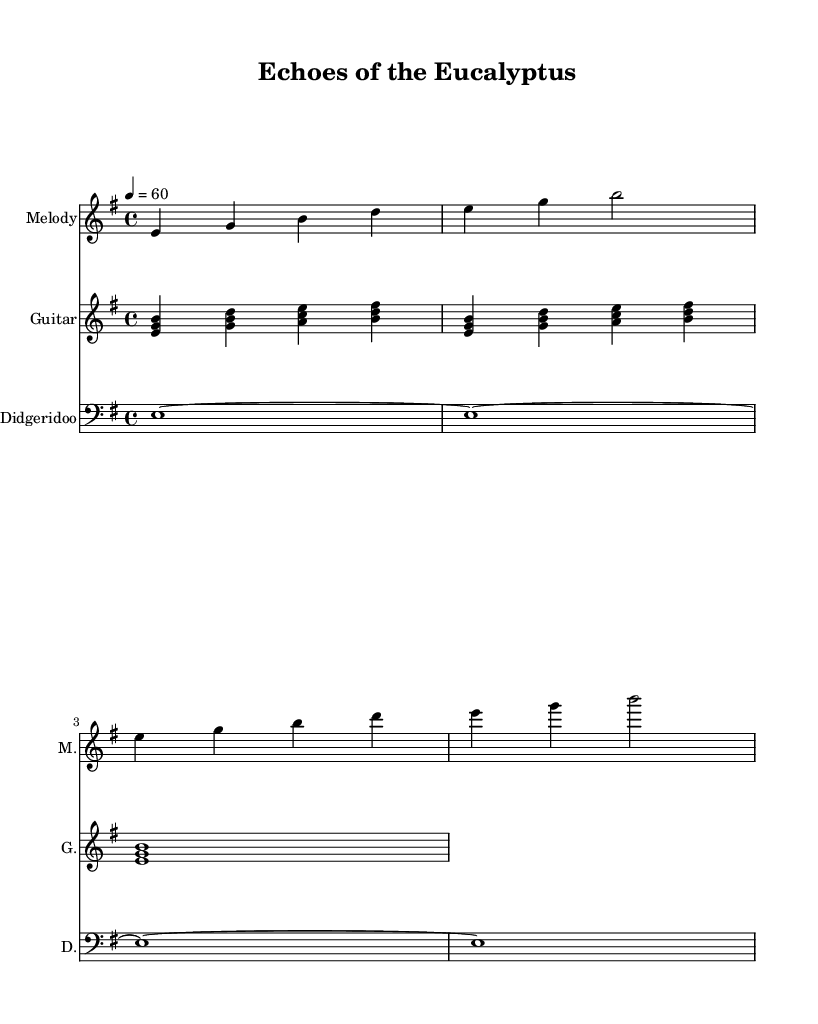What is the key signature of this music? The key signature is E minor, which has one sharp (F#). This can be identified by looking at the key signature at the beginning of the staff lines.
Answer: E minor What is the time signature of this piece? The time signature is 4/4, noted right after the key signature at the beginning of the score. This means there are four beats in a measure and the quarter note gets one beat.
Answer: 4/4 What is the tempo marking of the piece? The tempo marking is quarter note equals 60, which can be found in the header section of the music. This indicates that a quarter note gets a beats per minute count of 60.
Answer: 60 How many measures are in the melody section? The melody section contains four measures. This can be counted by looking at the vertical lines separating the measures in the melody staff.
Answer: 4 What instruments are featured in this piece? The instruments featured are melody, guitar, and didgeridoo. These are listed at the beginning of each respective staff.
Answer: Melody, Guitar, Didgeridoo What is the duration of the didgeridoo part? The didgeridoo part consists primarily of whole notes lasting for four measures. Each whole note is held for the entire duration of its measure.
Answer: Four measures How does the harmony change in the guitar part? The harmony changes with different chords across the measures. The guitar plays chords built on E minor, G major, A minor, and B major, which can be analyzed by looking at the notes played in each measure.
Answer: E minor, G major, A minor, B major 